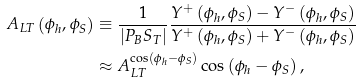<formula> <loc_0><loc_0><loc_500><loc_500>A _ { L T } \left ( \phi _ { h } , \phi _ { S } \right ) & \equiv \frac { 1 } { \left | P _ { B } S _ { T } \right | } \frac { Y ^ { + } \left ( \phi _ { h } , \phi _ { S } \right ) - Y ^ { - } \left ( \phi _ { h } , \phi _ { S } \right ) } { Y ^ { + } \left ( \phi _ { h } , \phi _ { S } \right ) + Y ^ { - } \left ( \phi _ { h } , \phi _ { S } \right ) } \\ & \approx A _ { L T } ^ { \cos \left ( \phi _ { h } - \phi _ { S } \right ) } \cos \left ( \phi _ { h } - \phi _ { S } \right ) ,</formula> 